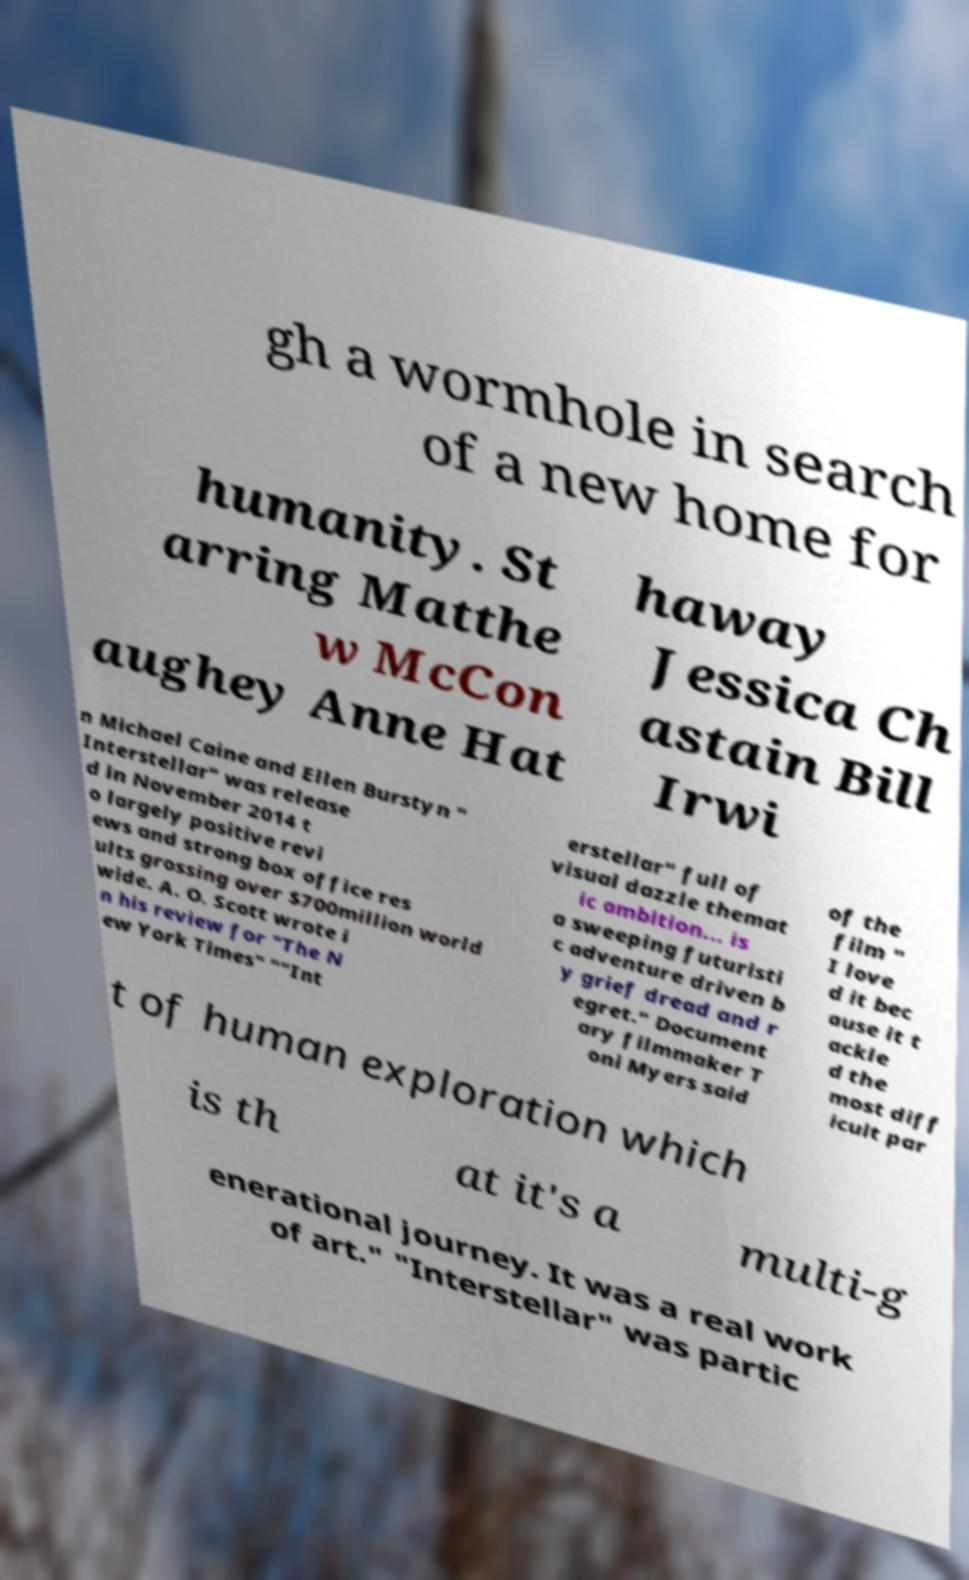There's text embedded in this image that I need extracted. Can you transcribe it verbatim? gh a wormhole in search of a new home for humanity. St arring Matthe w McCon aughey Anne Hat haway Jessica Ch astain Bill Irwi n Michael Caine and Ellen Burstyn " Interstellar" was release d in November 2014 t o largely positive revi ews and strong box office res ults grossing over $700million world wide. A. O. Scott wrote i n his review for "The N ew York Times" ""Int erstellar" full of visual dazzle themat ic ambition... is a sweeping futuristi c adventure driven b y grief dread and r egret." Document ary filmmaker T oni Myers said of the film " I love d it bec ause it t ackle d the most diff icult par t of human exploration which is th at it's a multi-g enerational journey. It was a real work of art." "Interstellar" was partic 